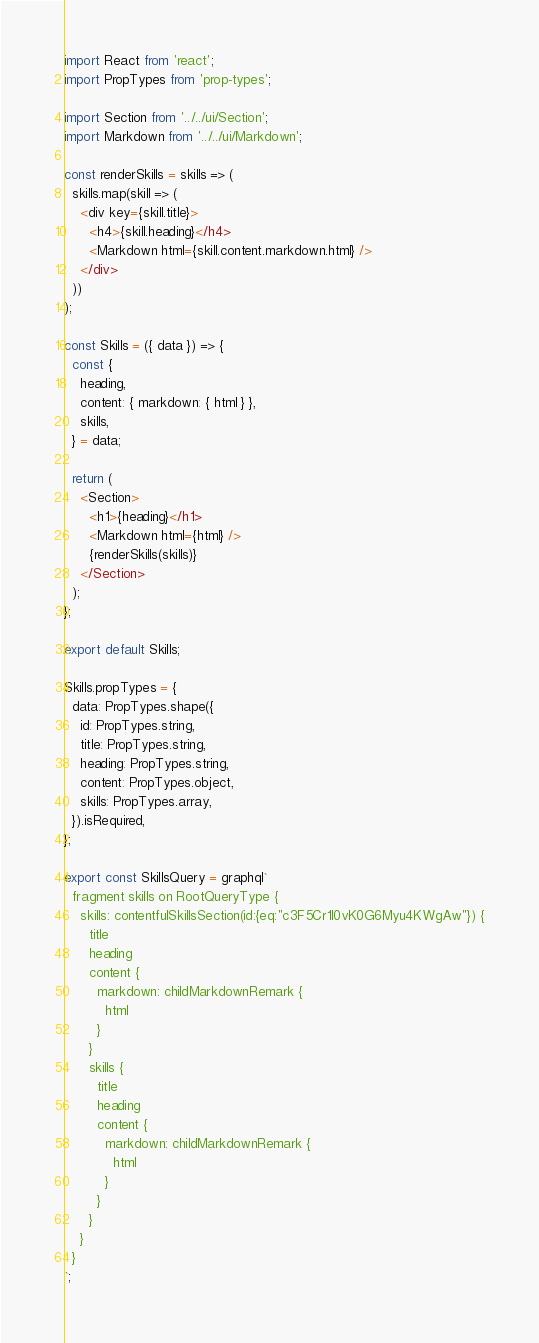<code> <loc_0><loc_0><loc_500><loc_500><_JavaScript_>import React from 'react';
import PropTypes from 'prop-types';

import Section from '../../ui/Section';
import Markdown from '../../ui/Markdown';

const renderSkills = skills => (
  skills.map(skill => (
    <div key={skill.title}>
      <h4>{skill.heading}</h4>
      <Markdown html={skill.content.markdown.html} />
    </div>
  ))
);

const Skills = ({ data }) => {
  const {
    heading,
    content: { markdown: { html } },
    skills,
  } = data;

  return (
    <Section>
      <h1>{heading}</h1>
      <Markdown html={html} />
      {renderSkills(skills)}
    </Section>
  );
};

export default Skills;

Skills.propTypes = {
  data: PropTypes.shape({
    id: PropTypes.string,
    title: PropTypes.string,
    heading: PropTypes.string,
    content: PropTypes.object,
    skills: PropTypes.array,
  }).isRequired,
};

export const SkillsQuery = graphql`
  fragment skills on RootQueryType {
    skills: contentfulSkillsSection(id:{eq:"c3F5Cr1I0vK0G6Myu4KWgAw"}) {
      title
      heading
      content {
        markdown: childMarkdownRemark {
          html
        }
      }
      skills {
        title
        heading
        content {
          markdown: childMarkdownRemark {
            html
          }
        }
      }
    }
  }
`;
</code> 